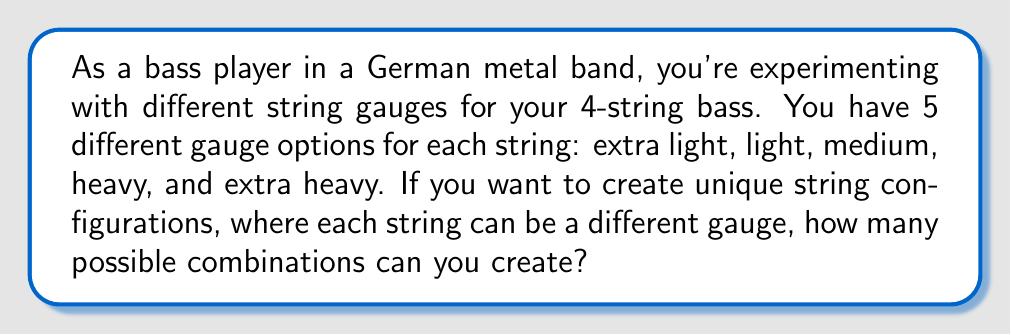Could you help me with this problem? Let's approach this step-by-step:

1) We have 4 strings on the bass guitar (E, A, D, G).

2) For each string, we have 5 gauge options.

3) This is a case of independent choices for each string, where the order matters (as each string position is fixed).

4) In such cases, we use the multiplication principle of counting.

5) For each string, we have 5 choices, and this is true for all 4 strings.

6) Therefore, the total number of possible combinations is:

   $$5 \times 5 \times 5 \times 5 = 5^4$$

7) We can calculate this:
   
   $$5^4 = 5 \times 5 \times 5 \times 5 = 625$$

Thus, there are 625 different possible string gauge configurations for your 4-string bass.
Answer: 625 